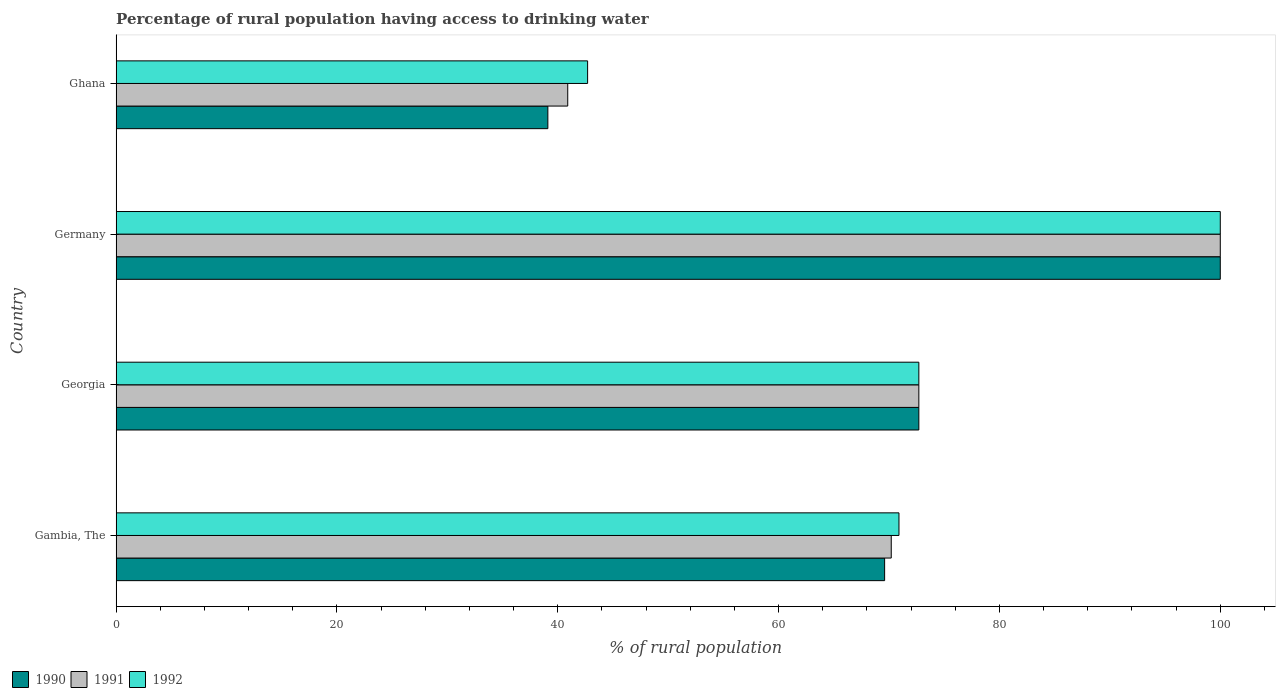How many different coloured bars are there?
Give a very brief answer. 3. Are the number of bars per tick equal to the number of legend labels?
Keep it short and to the point. Yes. Are the number of bars on each tick of the Y-axis equal?
Ensure brevity in your answer.  Yes. How many bars are there on the 3rd tick from the bottom?
Your answer should be very brief. 3. What is the percentage of rural population having access to drinking water in 1991 in Ghana?
Provide a short and direct response. 40.9. Across all countries, what is the maximum percentage of rural population having access to drinking water in 1992?
Offer a very short reply. 100. Across all countries, what is the minimum percentage of rural population having access to drinking water in 1991?
Ensure brevity in your answer.  40.9. What is the total percentage of rural population having access to drinking water in 1990 in the graph?
Offer a very short reply. 281.4. What is the difference between the percentage of rural population having access to drinking water in 1992 in Gambia, The and that in Ghana?
Provide a short and direct response. 28.2. What is the difference between the percentage of rural population having access to drinking water in 1991 in Ghana and the percentage of rural population having access to drinking water in 1992 in Georgia?
Make the answer very short. -31.8. What is the average percentage of rural population having access to drinking water in 1992 per country?
Provide a succinct answer. 71.58. What is the difference between the percentage of rural population having access to drinking water in 1992 and percentage of rural population having access to drinking water in 1990 in Gambia, The?
Provide a succinct answer. 1.3. What is the ratio of the percentage of rural population having access to drinking water in 1992 in Georgia to that in Ghana?
Keep it short and to the point. 1.7. What is the difference between the highest and the second highest percentage of rural population having access to drinking water in 1991?
Offer a terse response. 27.3. What is the difference between the highest and the lowest percentage of rural population having access to drinking water in 1991?
Offer a very short reply. 59.1. What does the 3rd bar from the bottom in Gambia, The represents?
Provide a succinct answer. 1992. How many bars are there?
Your response must be concise. 12. Are all the bars in the graph horizontal?
Give a very brief answer. Yes. How many countries are there in the graph?
Ensure brevity in your answer.  4. Does the graph contain grids?
Give a very brief answer. No. What is the title of the graph?
Make the answer very short. Percentage of rural population having access to drinking water. Does "1962" appear as one of the legend labels in the graph?
Offer a terse response. No. What is the label or title of the X-axis?
Your answer should be very brief. % of rural population. What is the label or title of the Y-axis?
Give a very brief answer. Country. What is the % of rural population of 1990 in Gambia, The?
Offer a terse response. 69.6. What is the % of rural population in 1991 in Gambia, The?
Provide a succinct answer. 70.2. What is the % of rural population of 1992 in Gambia, The?
Provide a succinct answer. 70.9. What is the % of rural population in 1990 in Georgia?
Your response must be concise. 72.7. What is the % of rural population in 1991 in Georgia?
Your answer should be compact. 72.7. What is the % of rural population in 1992 in Georgia?
Offer a very short reply. 72.7. What is the % of rural population of 1990 in Ghana?
Offer a terse response. 39.1. What is the % of rural population in 1991 in Ghana?
Make the answer very short. 40.9. What is the % of rural population in 1992 in Ghana?
Provide a succinct answer. 42.7. Across all countries, what is the maximum % of rural population of 1991?
Offer a terse response. 100. Across all countries, what is the minimum % of rural population of 1990?
Make the answer very short. 39.1. Across all countries, what is the minimum % of rural population in 1991?
Make the answer very short. 40.9. Across all countries, what is the minimum % of rural population of 1992?
Your answer should be compact. 42.7. What is the total % of rural population of 1990 in the graph?
Your response must be concise. 281.4. What is the total % of rural population in 1991 in the graph?
Keep it short and to the point. 283.8. What is the total % of rural population of 1992 in the graph?
Your response must be concise. 286.3. What is the difference between the % of rural population of 1991 in Gambia, The and that in Georgia?
Keep it short and to the point. -2.5. What is the difference between the % of rural population of 1992 in Gambia, The and that in Georgia?
Offer a terse response. -1.8. What is the difference between the % of rural population of 1990 in Gambia, The and that in Germany?
Provide a short and direct response. -30.4. What is the difference between the % of rural population in 1991 in Gambia, The and that in Germany?
Offer a terse response. -29.8. What is the difference between the % of rural population of 1992 in Gambia, The and that in Germany?
Give a very brief answer. -29.1. What is the difference between the % of rural population in 1990 in Gambia, The and that in Ghana?
Offer a terse response. 30.5. What is the difference between the % of rural population of 1991 in Gambia, The and that in Ghana?
Your response must be concise. 29.3. What is the difference between the % of rural population in 1992 in Gambia, The and that in Ghana?
Your answer should be very brief. 28.2. What is the difference between the % of rural population of 1990 in Georgia and that in Germany?
Make the answer very short. -27.3. What is the difference between the % of rural population in 1991 in Georgia and that in Germany?
Offer a very short reply. -27.3. What is the difference between the % of rural population in 1992 in Georgia and that in Germany?
Make the answer very short. -27.3. What is the difference between the % of rural population in 1990 in Georgia and that in Ghana?
Keep it short and to the point. 33.6. What is the difference between the % of rural population of 1991 in Georgia and that in Ghana?
Ensure brevity in your answer.  31.8. What is the difference between the % of rural population in 1992 in Georgia and that in Ghana?
Give a very brief answer. 30. What is the difference between the % of rural population of 1990 in Germany and that in Ghana?
Make the answer very short. 60.9. What is the difference between the % of rural population in 1991 in Germany and that in Ghana?
Offer a very short reply. 59.1. What is the difference between the % of rural population in 1992 in Germany and that in Ghana?
Provide a short and direct response. 57.3. What is the difference between the % of rural population of 1990 in Gambia, The and the % of rural population of 1992 in Georgia?
Make the answer very short. -3.1. What is the difference between the % of rural population of 1990 in Gambia, The and the % of rural population of 1991 in Germany?
Provide a succinct answer. -30.4. What is the difference between the % of rural population of 1990 in Gambia, The and the % of rural population of 1992 in Germany?
Provide a short and direct response. -30.4. What is the difference between the % of rural population in 1991 in Gambia, The and the % of rural population in 1992 in Germany?
Ensure brevity in your answer.  -29.8. What is the difference between the % of rural population in 1990 in Gambia, The and the % of rural population in 1991 in Ghana?
Your answer should be very brief. 28.7. What is the difference between the % of rural population of 1990 in Gambia, The and the % of rural population of 1992 in Ghana?
Your response must be concise. 26.9. What is the difference between the % of rural population of 1991 in Gambia, The and the % of rural population of 1992 in Ghana?
Keep it short and to the point. 27.5. What is the difference between the % of rural population in 1990 in Georgia and the % of rural population in 1991 in Germany?
Make the answer very short. -27.3. What is the difference between the % of rural population of 1990 in Georgia and the % of rural population of 1992 in Germany?
Keep it short and to the point. -27.3. What is the difference between the % of rural population in 1991 in Georgia and the % of rural population in 1992 in Germany?
Your response must be concise. -27.3. What is the difference between the % of rural population in 1990 in Georgia and the % of rural population in 1991 in Ghana?
Ensure brevity in your answer.  31.8. What is the difference between the % of rural population of 1990 in Georgia and the % of rural population of 1992 in Ghana?
Offer a very short reply. 30. What is the difference between the % of rural population of 1991 in Georgia and the % of rural population of 1992 in Ghana?
Your answer should be compact. 30. What is the difference between the % of rural population of 1990 in Germany and the % of rural population of 1991 in Ghana?
Your answer should be very brief. 59.1. What is the difference between the % of rural population in 1990 in Germany and the % of rural population in 1992 in Ghana?
Give a very brief answer. 57.3. What is the difference between the % of rural population of 1991 in Germany and the % of rural population of 1992 in Ghana?
Keep it short and to the point. 57.3. What is the average % of rural population in 1990 per country?
Your answer should be very brief. 70.35. What is the average % of rural population in 1991 per country?
Provide a short and direct response. 70.95. What is the average % of rural population of 1992 per country?
Your response must be concise. 71.58. What is the difference between the % of rural population in 1990 and % of rural population in 1992 in Gambia, The?
Your response must be concise. -1.3. What is the difference between the % of rural population in 1990 and % of rural population in 1991 in Georgia?
Your response must be concise. 0. What is the difference between the % of rural population of 1990 and % of rural population of 1992 in Georgia?
Your answer should be compact. 0. What is the difference between the % of rural population in 1990 and % of rural population in 1992 in Germany?
Provide a succinct answer. 0. What is the difference between the % of rural population in 1991 and % of rural population in 1992 in Germany?
Offer a very short reply. 0. What is the difference between the % of rural population of 1990 and % of rural population of 1991 in Ghana?
Your answer should be compact. -1.8. What is the difference between the % of rural population in 1990 and % of rural population in 1992 in Ghana?
Provide a short and direct response. -3.6. What is the difference between the % of rural population of 1991 and % of rural population of 1992 in Ghana?
Provide a short and direct response. -1.8. What is the ratio of the % of rural population of 1990 in Gambia, The to that in Georgia?
Your answer should be very brief. 0.96. What is the ratio of the % of rural population in 1991 in Gambia, The to that in Georgia?
Offer a terse response. 0.97. What is the ratio of the % of rural population in 1992 in Gambia, The to that in Georgia?
Your response must be concise. 0.98. What is the ratio of the % of rural population in 1990 in Gambia, The to that in Germany?
Offer a terse response. 0.7. What is the ratio of the % of rural population in 1991 in Gambia, The to that in Germany?
Your response must be concise. 0.7. What is the ratio of the % of rural population of 1992 in Gambia, The to that in Germany?
Offer a terse response. 0.71. What is the ratio of the % of rural population in 1990 in Gambia, The to that in Ghana?
Keep it short and to the point. 1.78. What is the ratio of the % of rural population of 1991 in Gambia, The to that in Ghana?
Keep it short and to the point. 1.72. What is the ratio of the % of rural population of 1992 in Gambia, The to that in Ghana?
Offer a very short reply. 1.66. What is the ratio of the % of rural population in 1990 in Georgia to that in Germany?
Your response must be concise. 0.73. What is the ratio of the % of rural population in 1991 in Georgia to that in Germany?
Your answer should be very brief. 0.73. What is the ratio of the % of rural population of 1992 in Georgia to that in Germany?
Provide a succinct answer. 0.73. What is the ratio of the % of rural population of 1990 in Georgia to that in Ghana?
Offer a very short reply. 1.86. What is the ratio of the % of rural population in 1991 in Georgia to that in Ghana?
Give a very brief answer. 1.78. What is the ratio of the % of rural population in 1992 in Georgia to that in Ghana?
Offer a terse response. 1.7. What is the ratio of the % of rural population in 1990 in Germany to that in Ghana?
Offer a terse response. 2.56. What is the ratio of the % of rural population of 1991 in Germany to that in Ghana?
Your response must be concise. 2.44. What is the ratio of the % of rural population of 1992 in Germany to that in Ghana?
Offer a very short reply. 2.34. What is the difference between the highest and the second highest % of rural population in 1990?
Your answer should be very brief. 27.3. What is the difference between the highest and the second highest % of rural population of 1991?
Offer a very short reply. 27.3. What is the difference between the highest and the second highest % of rural population of 1992?
Provide a short and direct response. 27.3. What is the difference between the highest and the lowest % of rural population of 1990?
Your response must be concise. 60.9. What is the difference between the highest and the lowest % of rural population of 1991?
Your answer should be compact. 59.1. What is the difference between the highest and the lowest % of rural population in 1992?
Your answer should be very brief. 57.3. 